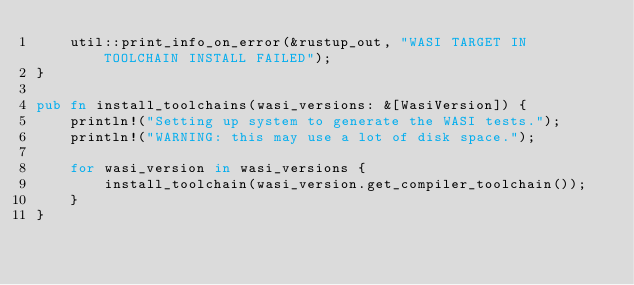<code> <loc_0><loc_0><loc_500><loc_500><_Rust_>    util::print_info_on_error(&rustup_out, "WASI TARGET IN TOOLCHAIN INSTALL FAILED");
}

pub fn install_toolchains(wasi_versions: &[WasiVersion]) {
    println!("Setting up system to generate the WASI tests.");
    println!("WARNING: this may use a lot of disk space.");

    for wasi_version in wasi_versions {
        install_toolchain(wasi_version.get_compiler_toolchain());
    }
}
</code> 